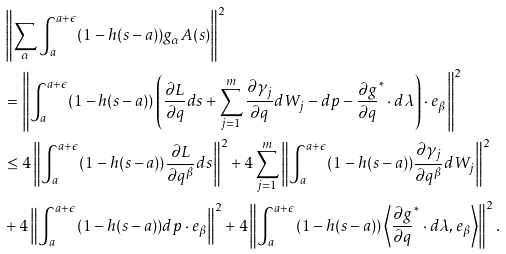<formula> <loc_0><loc_0><loc_500><loc_500>& \left \| \sum _ { \alpha } \int _ { a } ^ { a + \epsilon } ( 1 - h ( s - a ) ) g _ { \alpha } A ( s ) \right \| ^ { 2 } \\ & = \left \| \int _ { a } ^ { a + \epsilon } ( 1 - h ( s - a ) ) \left ( \frac { \partial L } { \partial q } d s + \sum _ { j = 1 } ^ { m } \frac { \partial \gamma _ { j } } { \partial q } d W _ { j } - d p - \frac { \partial g } { \partial q } ^ { * } \cdot d \lambda \right ) \cdot e _ { \beta } \right \| ^ { 2 } \\ & \leq 4 \left \| \int _ { a } ^ { a + \epsilon } ( 1 - h ( s - a ) ) \frac { \partial L } { \partial q ^ { \beta } } d s \right \| ^ { 2 } + 4 \sum _ { j = 1 } ^ { m } \left \| \int _ { a } ^ { a + \epsilon } ( 1 - h ( s - a ) ) \frac { \partial \gamma _ { j } } { \partial q ^ { \beta } } d W _ { j } \right \| ^ { 2 } \\ & + 4 \left \| \int _ { a } ^ { a + \epsilon } ( 1 - h ( s - a ) ) d p \cdot e _ { \beta } \right \| ^ { 2 } + 4 \left \| \int _ { a } ^ { a + \epsilon } ( 1 - h ( s - a ) ) \left \langle \frac { \partial g } { \partial q } ^ { * } \cdot d \lambda , e _ { \beta } \right \rangle \right \| ^ { 2 } \text {.}</formula> 